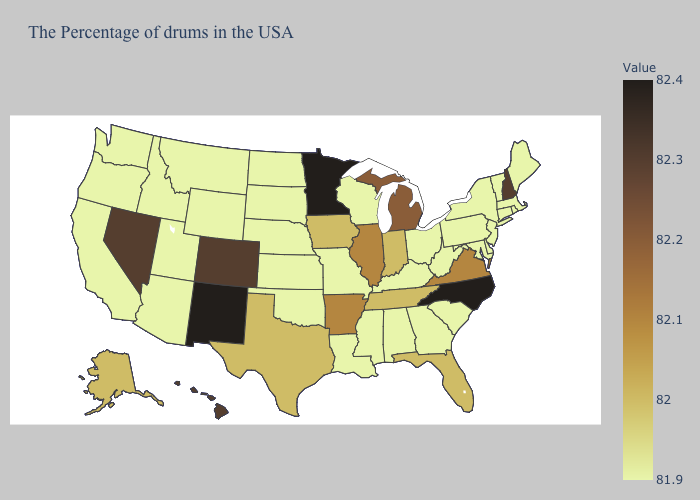Does Alaska have the highest value in the USA?
Give a very brief answer. No. Which states have the highest value in the USA?
Give a very brief answer. North Carolina, Minnesota, New Mexico. Which states have the lowest value in the MidWest?
Be succinct. Ohio, Wisconsin, Missouri, Kansas, Nebraska, South Dakota, North Dakota. 